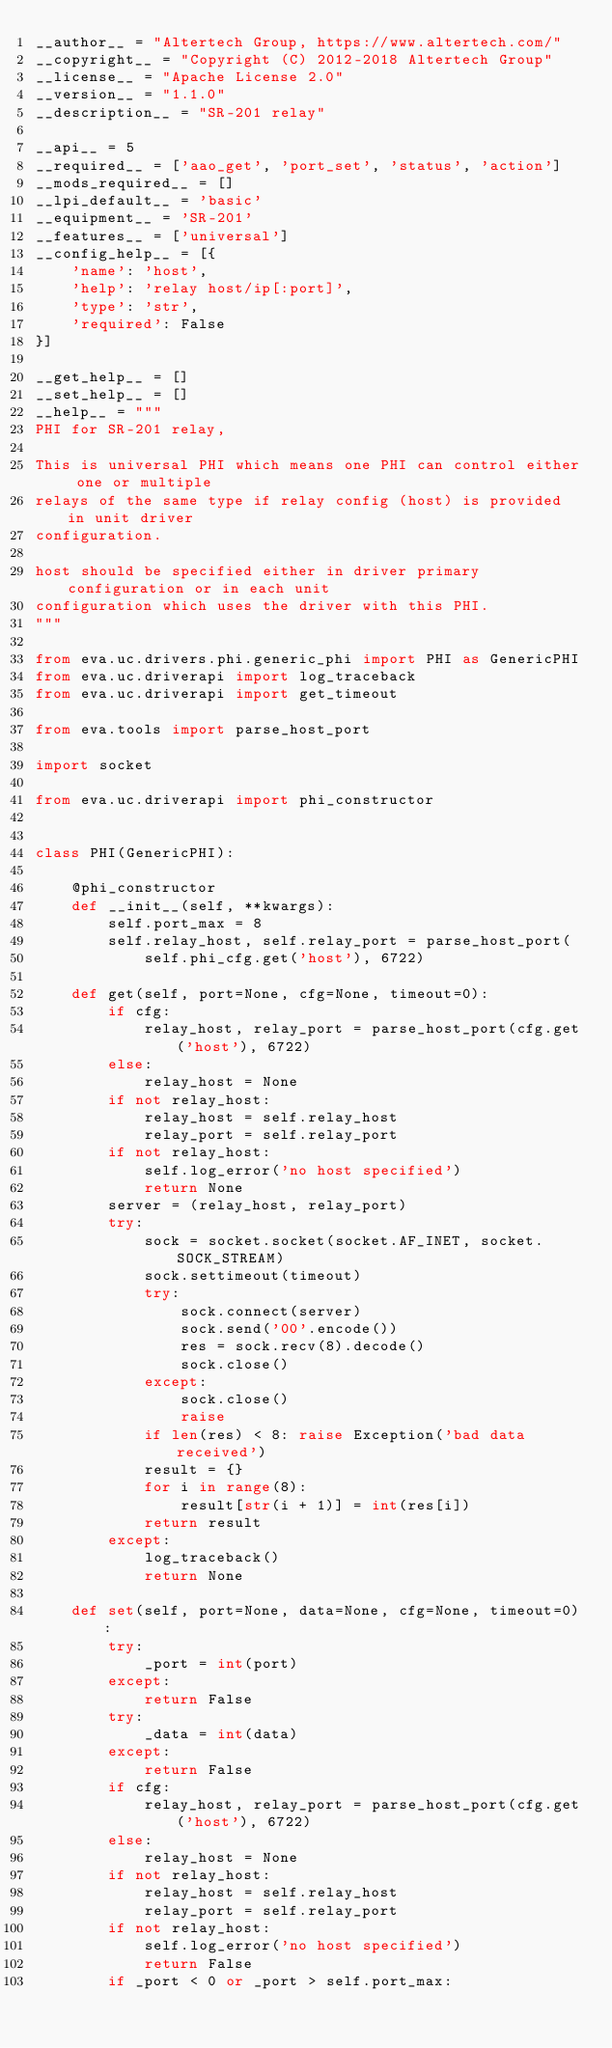Convert code to text. <code><loc_0><loc_0><loc_500><loc_500><_Python_>__author__ = "Altertech Group, https://www.altertech.com/"
__copyright__ = "Copyright (C) 2012-2018 Altertech Group"
__license__ = "Apache License 2.0"
__version__ = "1.1.0"
__description__ = "SR-201 relay"

__api__ = 5
__required__ = ['aao_get', 'port_set', 'status', 'action']
__mods_required__ = []
__lpi_default__ = 'basic'
__equipment__ = 'SR-201'
__features__ = ['universal']
__config_help__ = [{
    'name': 'host',
    'help': 'relay host/ip[:port]',
    'type': 'str',
    'required': False
}]

__get_help__ = []
__set_help__ = []
__help__ = """
PHI for SR-201 relay,

This is universal PHI which means one PHI can control either one or multiple
relays of the same type if relay config (host) is provided in unit driver
configuration.

host should be specified either in driver primary configuration or in each unit
configuration which uses the driver with this PHI.
"""

from eva.uc.drivers.phi.generic_phi import PHI as GenericPHI
from eva.uc.driverapi import log_traceback
from eva.uc.driverapi import get_timeout

from eva.tools import parse_host_port

import socket

from eva.uc.driverapi import phi_constructor


class PHI(GenericPHI):

    @phi_constructor
    def __init__(self, **kwargs):
        self.port_max = 8
        self.relay_host, self.relay_port = parse_host_port(
            self.phi_cfg.get('host'), 6722)

    def get(self, port=None, cfg=None, timeout=0):
        if cfg:
            relay_host, relay_port = parse_host_port(cfg.get('host'), 6722)
        else:
            relay_host = None
        if not relay_host:
            relay_host = self.relay_host
            relay_port = self.relay_port
        if not relay_host:
            self.log_error('no host specified')
            return None
        server = (relay_host, relay_port)
        try:
            sock = socket.socket(socket.AF_INET, socket.SOCK_STREAM)
            sock.settimeout(timeout)
            try:
                sock.connect(server)
                sock.send('00'.encode())
                res = sock.recv(8).decode()
                sock.close()
            except:
                sock.close()
                raise
            if len(res) < 8: raise Exception('bad data received')
            result = {}
            for i in range(8):
                result[str(i + 1)] = int(res[i])
            return result
        except:
            log_traceback()
            return None

    def set(self, port=None, data=None, cfg=None, timeout=0):
        try:
            _port = int(port)
        except:
            return False
        try:
            _data = int(data)
        except:
            return False
        if cfg:
            relay_host, relay_port = parse_host_port(cfg.get('host'), 6722)
        else:
            relay_host = None
        if not relay_host:
            relay_host = self.relay_host
            relay_port = self.relay_port
        if not relay_host:
            self.log_error('no host specified')
            return False
        if _port < 0 or _port > self.port_max:</code> 